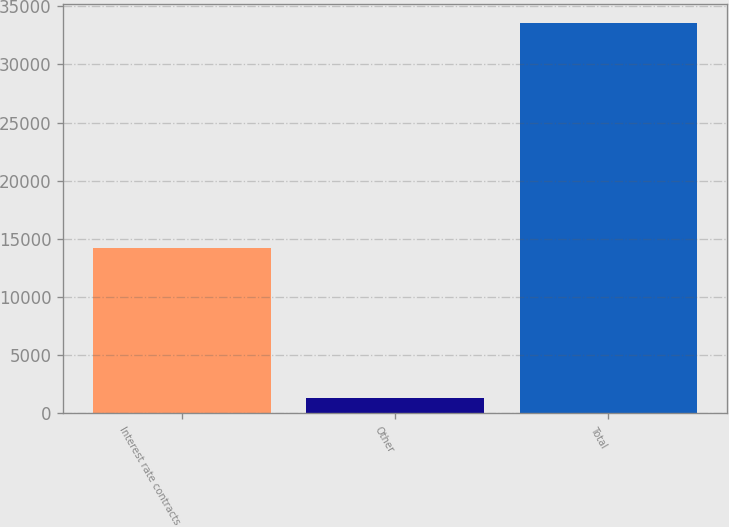Convert chart to OTSL. <chart><loc_0><loc_0><loc_500><loc_500><bar_chart><fcel>Interest rate contracts<fcel>Other<fcel>Total<nl><fcel>14228<fcel>1340<fcel>33528<nl></chart> 